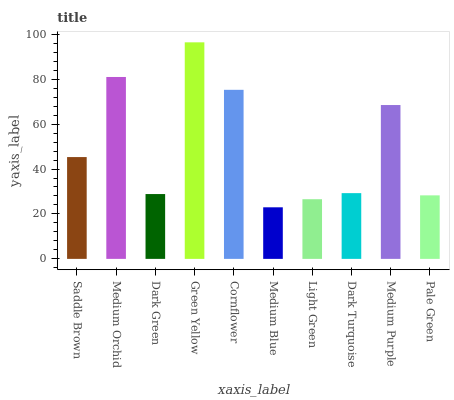Is Medium Blue the minimum?
Answer yes or no. Yes. Is Green Yellow the maximum?
Answer yes or no. Yes. Is Medium Orchid the minimum?
Answer yes or no. No. Is Medium Orchid the maximum?
Answer yes or no. No. Is Medium Orchid greater than Saddle Brown?
Answer yes or no. Yes. Is Saddle Brown less than Medium Orchid?
Answer yes or no. Yes. Is Saddle Brown greater than Medium Orchid?
Answer yes or no. No. Is Medium Orchid less than Saddle Brown?
Answer yes or no. No. Is Saddle Brown the high median?
Answer yes or no. Yes. Is Dark Turquoise the low median?
Answer yes or no. Yes. Is Dark Green the high median?
Answer yes or no. No. Is Pale Green the low median?
Answer yes or no. No. 